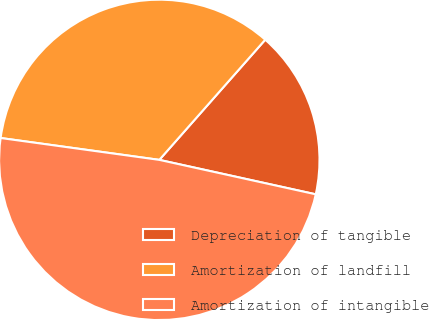Convert chart to OTSL. <chart><loc_0><loc_0><loc_500><loc_500><pie_chart><fcel>Depreciation of tangible<fcel>Amortization of landfill<fcel>Amortization of intangible<nl><fcel>16.95%<fcel>34.32%<fcel>48.73%<nl></chart> 